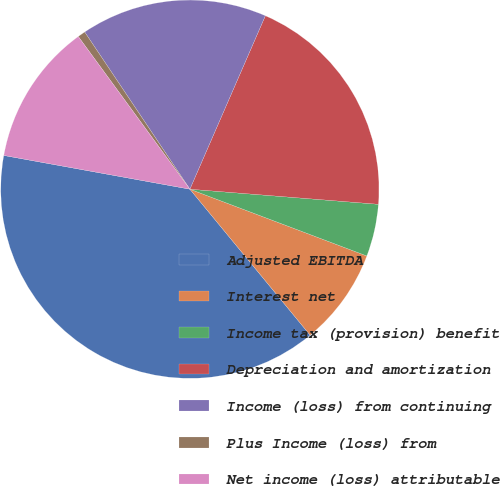Convert chart. <chart><loc_0><loc_0><loc_500><loc_500><pie_chart><fcel>Adjusted EBITDA<fcel>Interest net<fcel>Income tax (provision) benefit<fcel>Depreciation and amortization<fcel>Income (loss) from continuing<fcel>Plus Income (loss) from<fcel>Net income (loss) attributable<nl><fcel>38.82%<fcel>8.29%<fcel>4.47%<fcel>19.74%<fcel>15.92%<fcel>0.66%<fcel>12.1%<nl></chart> 